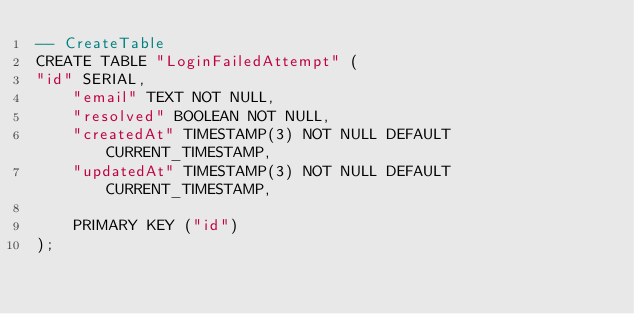Convert code to text. <code><loc_0><loc_0><loc_500><loc_500><_SQL_>-- CreateTable
CREATE TABLE "LoginFailedAttempt" (
"id" SERIAL,
    "email" TEXT NOT NULL,
    "resolved" BOOLEAN NOT NULL,
    "createdAt" TIMESTAMP(3) NOT NULL DEFAULT CURRENT_TIMESTAMP,
    "updatedAt" TIMESTAMP(3) NOT NULL DEFAULT CURRENT_TIMESTAMP,

    PRIMARY KEY ("id")
);
</code> 